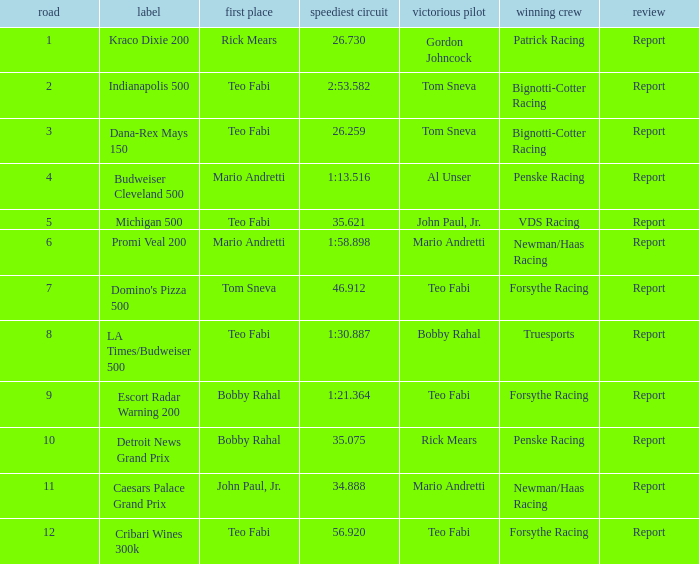What was the fastest lap time in the Escort Radar Warning 200? 1:21.364. 